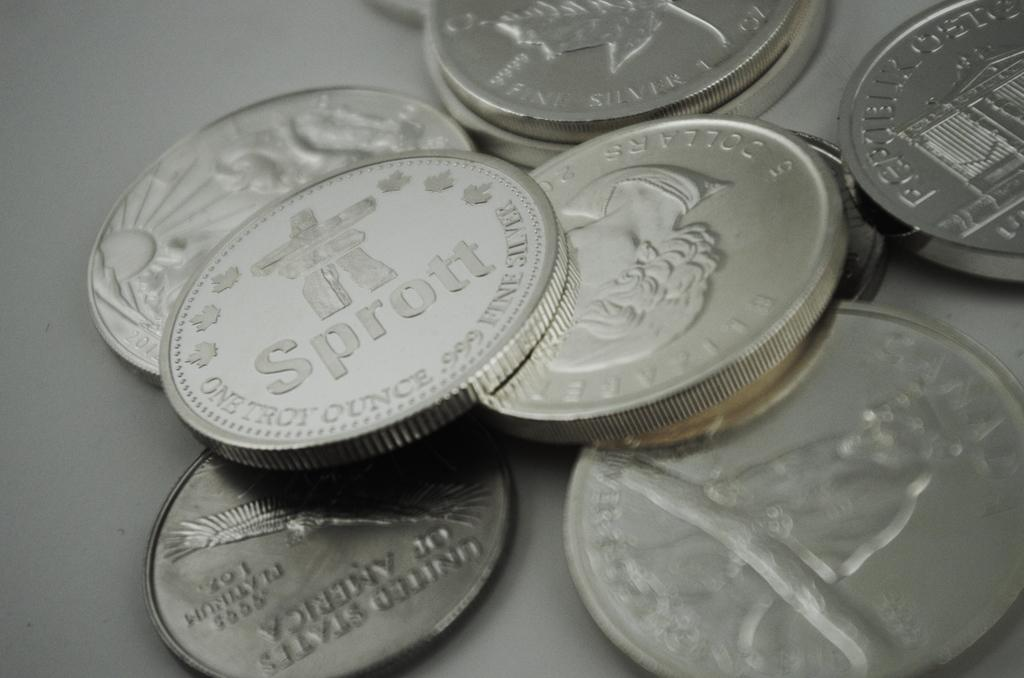<image>
Write a terse but informative summary of the picture. Silver coins are casually arranged with one saying Sprott. 